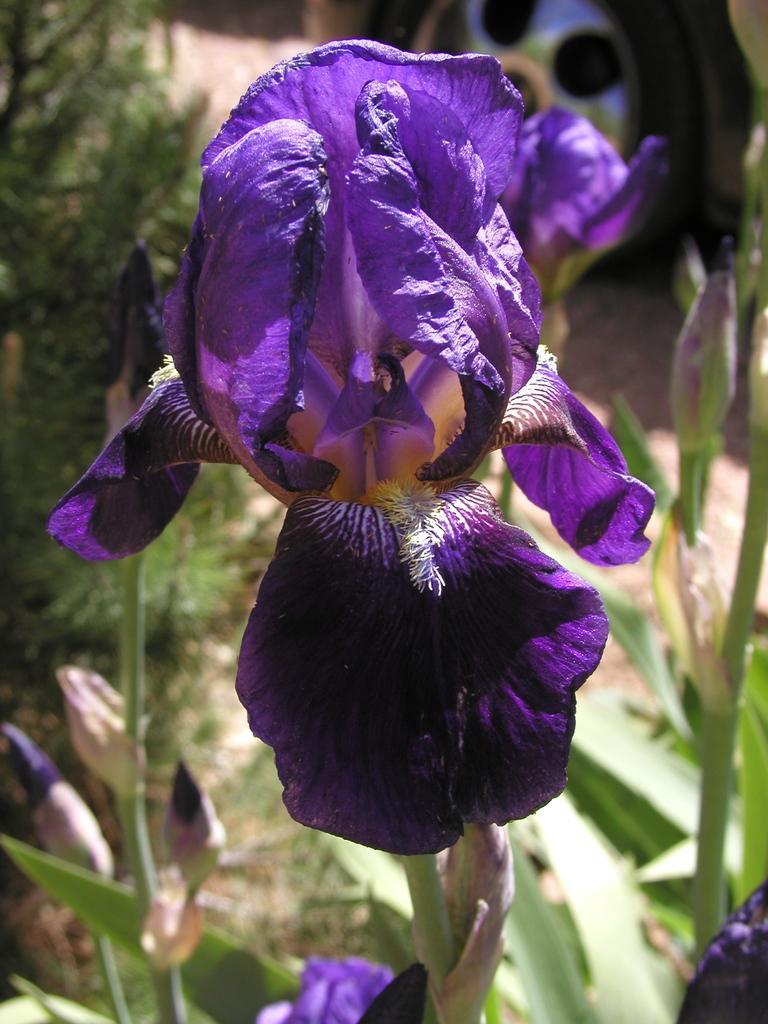Can you describe this image briefly? In this image we can see few plants. There are few flowers to a plant. There is a vehicle at the top left side of the image. 